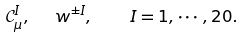<formula> <loc_0><loc_0><loc_500><loc_500>\mathcal { C } _ { \mu } ^ { I } , \text { \ } w ^ { \pm I } , \quad I = 1 , \cdots , 2 0 .</formula> 